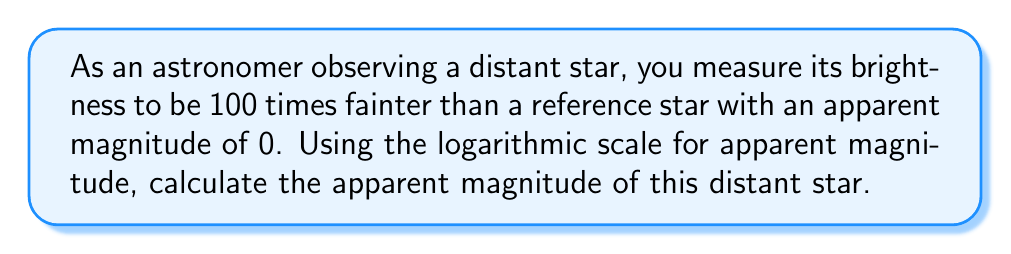Can you solve this math problem? To solve this problem, we need to use the logarithmic scale for apparent magnitude. The apparent magnitude (m) of a star is related to its brightness (b) relative to a reference star with known magnitude (m_ref) by the following equation:

$$ m - m_{\text{ref}} = -2.5 \log_{10}\left(\frac{b}{b_{\text{ref}}}\right) $$

Given:
- The reference star has an apparent magnitude of 0 (m_ref = 0)
- The observed star is 100 times fainter than the reference star

This means that the brightness ratio is:

$$ \frac{b}{b_{\text{ref}}} = \frac{1}{100} = 0.01 $$

Now, let's substitute these values into the equation:

$$ m - 0 = -2.5 \log_{10}(0.01) $$

Simplify:

$$ m = -2.5 \log_{10}(0.01) $$

Calculate the logarithm:

$$ m = -2.5 \times (-2) $$

$$ m = 5 $$

Therefore, the apparent magnitude of the distant star is 5.
Answer: The apparent magnitude of the distant star is 5. 